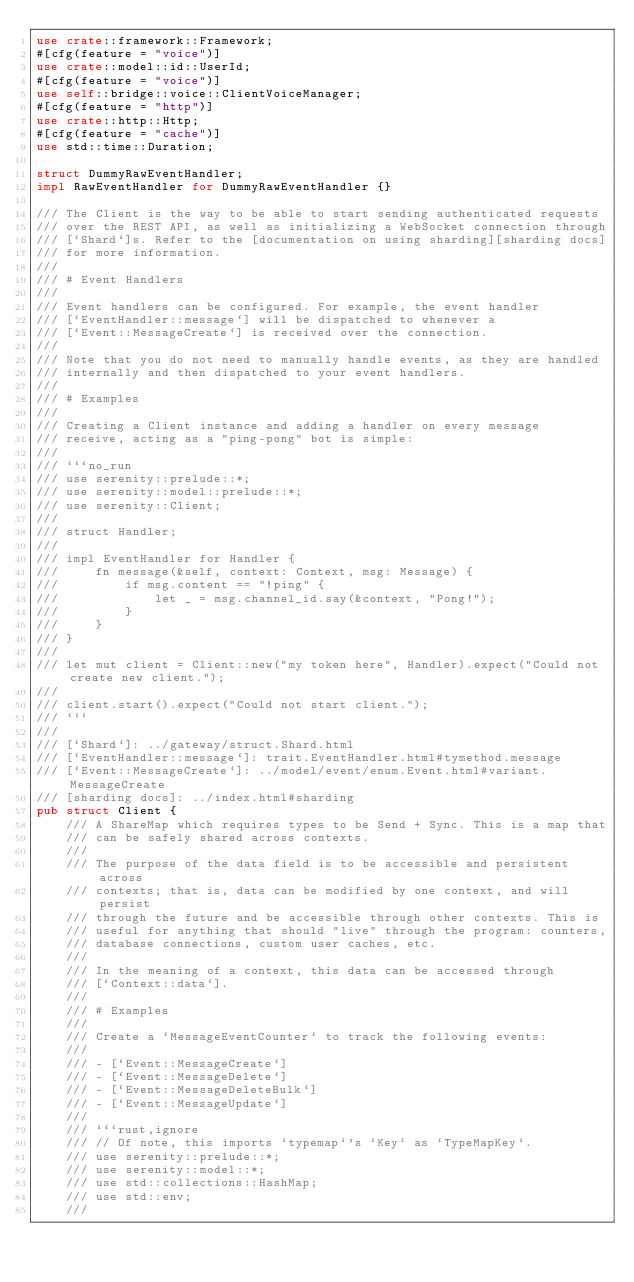<code> <loc_0><loc_0><loc_500><loc_500><_Rust_>use crate::framework::Framework;
#[cfg(feature = "voice")]
use crate::model::id::UserId;
#[cfg(feature = "voice")]
use self::bridge::voice::ClientVoiceManager;
#[cfg(feature = "http")]
use crate::http::Http;
#[cfg(feature = "cache")]
use std::time::Duration;

struct DummyRawEventHandler;
impl RawEventHandler for DummyRawEventHandler {}

/// The Client is the way to be able to start sending authenticated requests
/// over the REST API, as well as initializing a WebSocket connection through
/// [`Shard`]s. Refer to the [documentation on using sharding][sharding docs]
/// for more information.
///
/// # Event Handlers
///
/// Event handlers can be configured. For example, the event handler
/// [`EventHandler::message`] will be dispatched to whenever a
/// [`Event::MessageCreate`] is received over the connection.
///
/// Note that you do not need to manually handle events, as they are handled
/// internally and then dispatched to your event handlers.
///
/// # Examples
///
/// Creating a Client instance and adding a handler on every message
/// receive, acting as a "ping-pong" bot is simple:
///
/// ```no_run
/// use serenity::prelude::*;
/// use serenity::model::prelude::*;
/// use serenity::Client;
///
/// struct Handler;
///
/// impl EventHandler for Handler {
///     fn message(&self, context: Context, msg: Message) {
///         if msg.content == "!ping" {
///             let _ = msg.channel_id.say(&context, "Pong!");
///         }
///     }
/// }
///
/// let mut client = Client::new("my token here", Handler).expect("Could not create new client.");
///
/// client.start().expect("Could not start client.");
/// ```
///
/// [`Shard`]: ../gateway/struct.Shard.html
/// [`EventHandler::message`]: trait.EventHandler.html#tymethod.message
/// [`Event::MessageCreate`]: ../model/event/enum.Event.html#variant.MessageCreate
/// [sharding docs]: ../index.html#sharding
pub struct Client {
    /// A ShareMap which requires types to be Send + Sync. This is a map that
    /// can be safely shared across contexts.
    ///
    /// The purpose of the data field is to be accessible and persistent across
    /// contexts; that is, data can be modified by one context, and will persist
    /// through the future and be accessible through other contexts. This is
    /// useful for anything that should "live" through the program: counters,
    /// database connections, custom user caches, etc.
    ///
    /// In the meaning of a context, this data can be accessed through
    /// [`Context::data`].
    ///
    /// # Examples
    ///
    /// Create a `MessageEventCounter` to track the following events:
    ///
    /// - [`Event::MessageCreate`]
    /// - [`Event::MessageDelete`]
    /// - [`Event::MessageDeleteBulk`]
    /// - [`Event::MessageUpdate`]
    ///
    /// ```rust,ignore
    /// // Of note, this imports `typemap`'s `Key` as `TypeMapKey`.
    /// use serenity::prelude::*;
    /// use serenity::model::*;
    /// use std::collections::HashMap;
    /// use std::env;
    ///</code> 